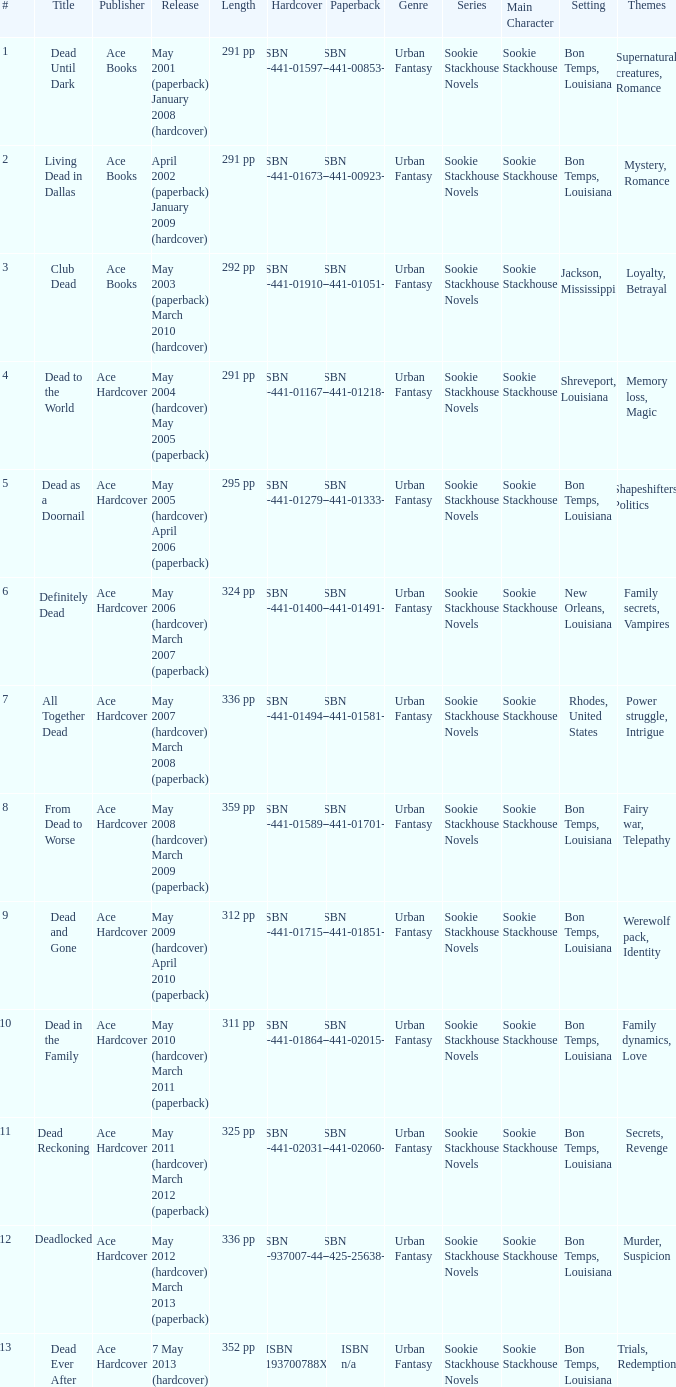How many publishers put out isbn 193700788x? 1.0. 